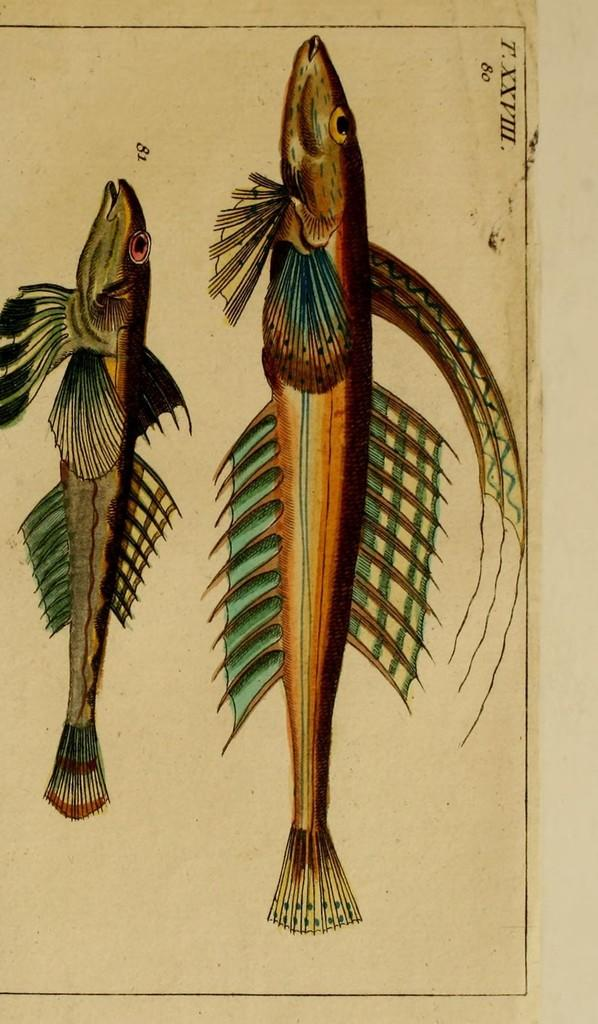What is featured on the poster in the image? There is a poster in the image, and it features two fishes. What else can be seen on the poster besides the fishes? There is text and numerical numbers on the poster. How many taxes are mentioned on the poster? There is no mention of taxes on the poster; it features two fishes, text, and numerical numbers. 